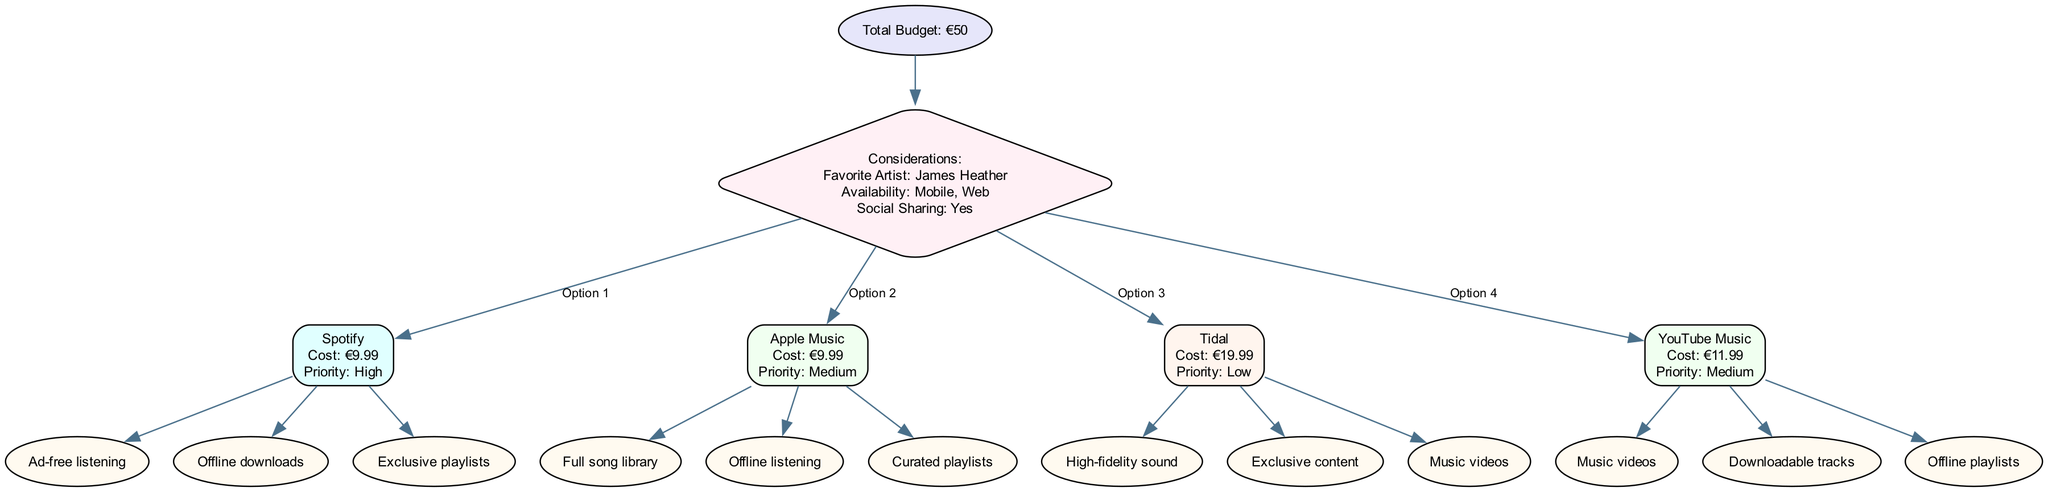What is the total budget for music subscriptions? The diagram shows the root node stating the total budget explicitly as "Total Budget: €50".
Answer: €50 What is the priority of the Spotify subscription? By examining the Spotify node within the subscriptions section of the diagram, it indicates "Priority: High."
Answer: High How many included features does Tidal have? The Tidal subscription node lists three included features "High-fidelity sound", "Exclusive content", and "Music videos", which can be counted to reach the answer.
Answer: 3 Which service has the highest cost? Looking at the costs within each subscription node, Tidal has a cost of €19.99, which is higher than the others listed.
Answer: Tidal What is the first consideration listed in the diagram? The considerations section details specific factors, with the first being "Favorite Artist: James Heather". This indicates what is most significant.
Answer: Favorite Artist: James Heather If I spend my entire budget on subscriptions, which service would I choose first? Given the costs and priorities, choosing Spotify first would be wise as it has a high priority and the lowest cost, allowing for maximum allocation within budget.
Answer: Spotify Which subscription option has downloadable tracks as part of its features? The YouTube Music subscription node indicates that it includes "Downloadable tracks."
Answer: YouTube Music Name the type of sharing noted in the diagram. The consideration section mentions "Social Sharing: Yes," indicating this specific feature regarding interaction.
Answer: Yes What is the total number of subscriptions listed in the diagram? After reviewing all the subscription nodes, there are four subscriptions detailed: Spotify, Apple Music, Tidal, and YouTube Music.
Answer: 4 